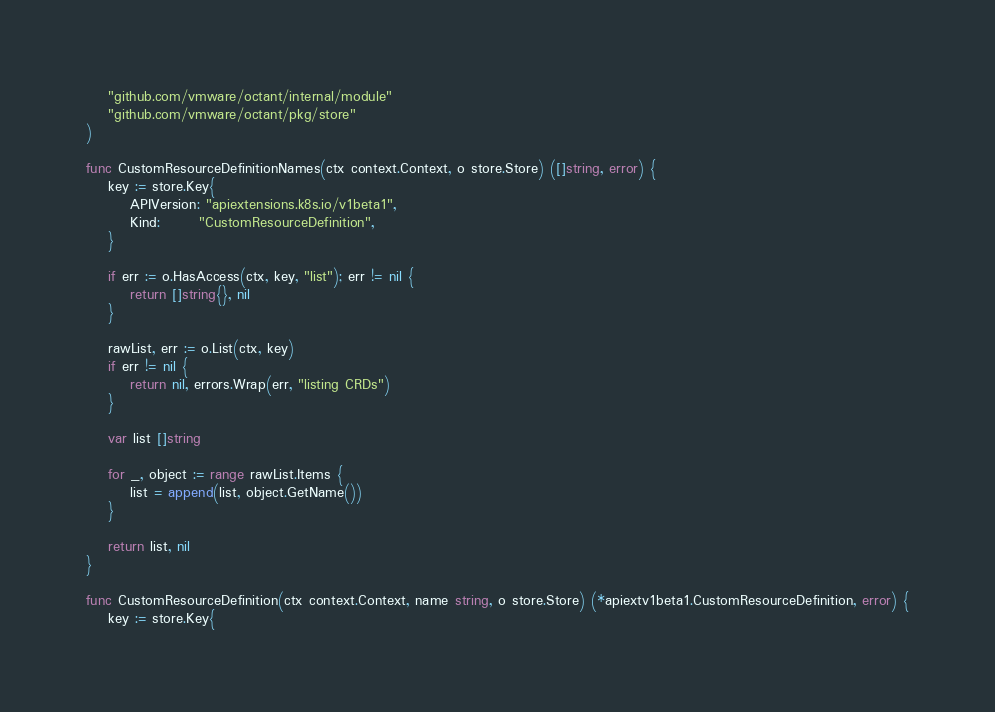Convert code to text. <code><loc_0><loc_0><loc_500><loc_500><_Go_>	"github.com/vmware/octant/internal/module"
	"github.com/vmware/octant/pkg/store"
)

func CustomResourceDefinitionNames(ctx context.Context, o store.Store) ([]string, error) {
	key := store.Key{
		APIVersion: "apiextensions.k8s.io/v1beta1",
		Kind:       "CustomResourceDefinition",
	}

	if err := o.HasAccess(ctx, key, "list"); err != nil {
		return []string{}, nil
	}

	rawList, err := o.List(ctx, key)
	if err != nil {
		return nil, errors.Wrap(err, "listing CRDs")
	}

	var list []string

	for _, object := range rawList.Items {
		list = append(list, object.GetName())
	}

	return list, nil
}

func CustomResourceDefinition(ctx context.Context, name string, o store.Store) (*apiextv1beta1.CustomResourceDefinition, error) {
	key := store.Key{</code> 